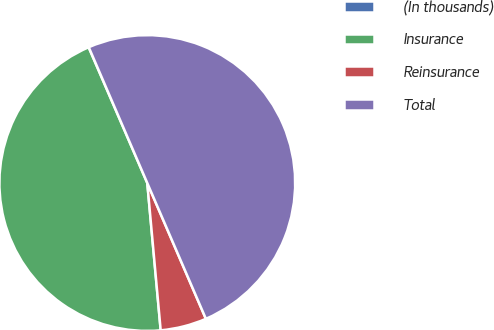<chart> <loc_0><loc_0><loc_500><loc_500><pie_chart><fcel>(In thousands)<fcel>Insurance<fcel>Reinsurance<fcel>Total<nl><fcel>0.02%<fcel>44.95%<fcel>5.04%<fcel>49.99%<nl></chart> 